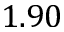Convert formula to latex. <formula><loc_0><loc_0><loc_500><loc_500>1 . 9 0</formula> 